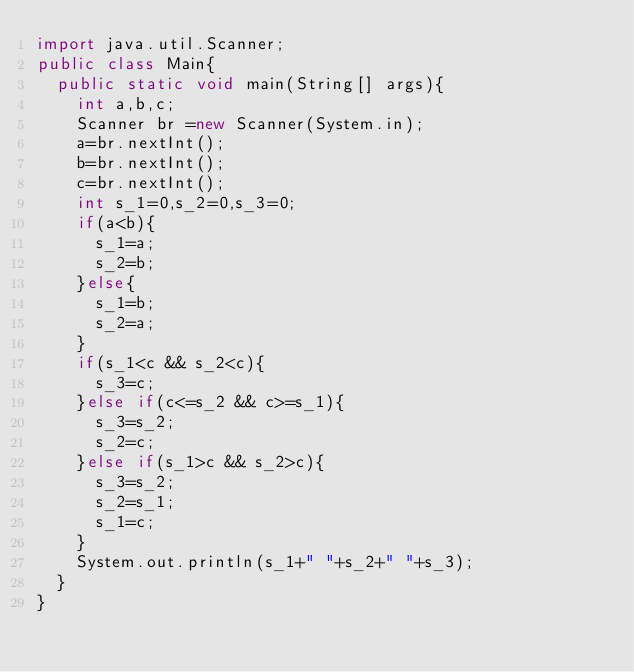Convert code to text. <code><loc_0><loc_0><loc_500><loc_500><_Java_>import java.util.Scanner;
public class Main{
	public static void main(String[] args){
		int a,b,c;
		Scanner br =new Scanner(System.in);
		a=br.nextInt();
		b=br.nextInt();
		c=br.nextInt();
		int s_1=0,s_2=0,s_3=0;
		if(a<b){
			s_1=a;
			s_2=b;
		}else{
			s_1=b;
			s_2=a;
		}
		if(s_1<c && s_2<c){
			s_3=c;
		}else if(c<=s_2 && c>=s_1){
			s_3=s_2;
			s_2=c;
		}else if(s_1>c && s_2>c){
			s_3=s_2;
			s_2=s_1;
			s_1=c;
		}
		System.out.println(s_1+" "+s_2+" "+s_3);
	}
}</code> 